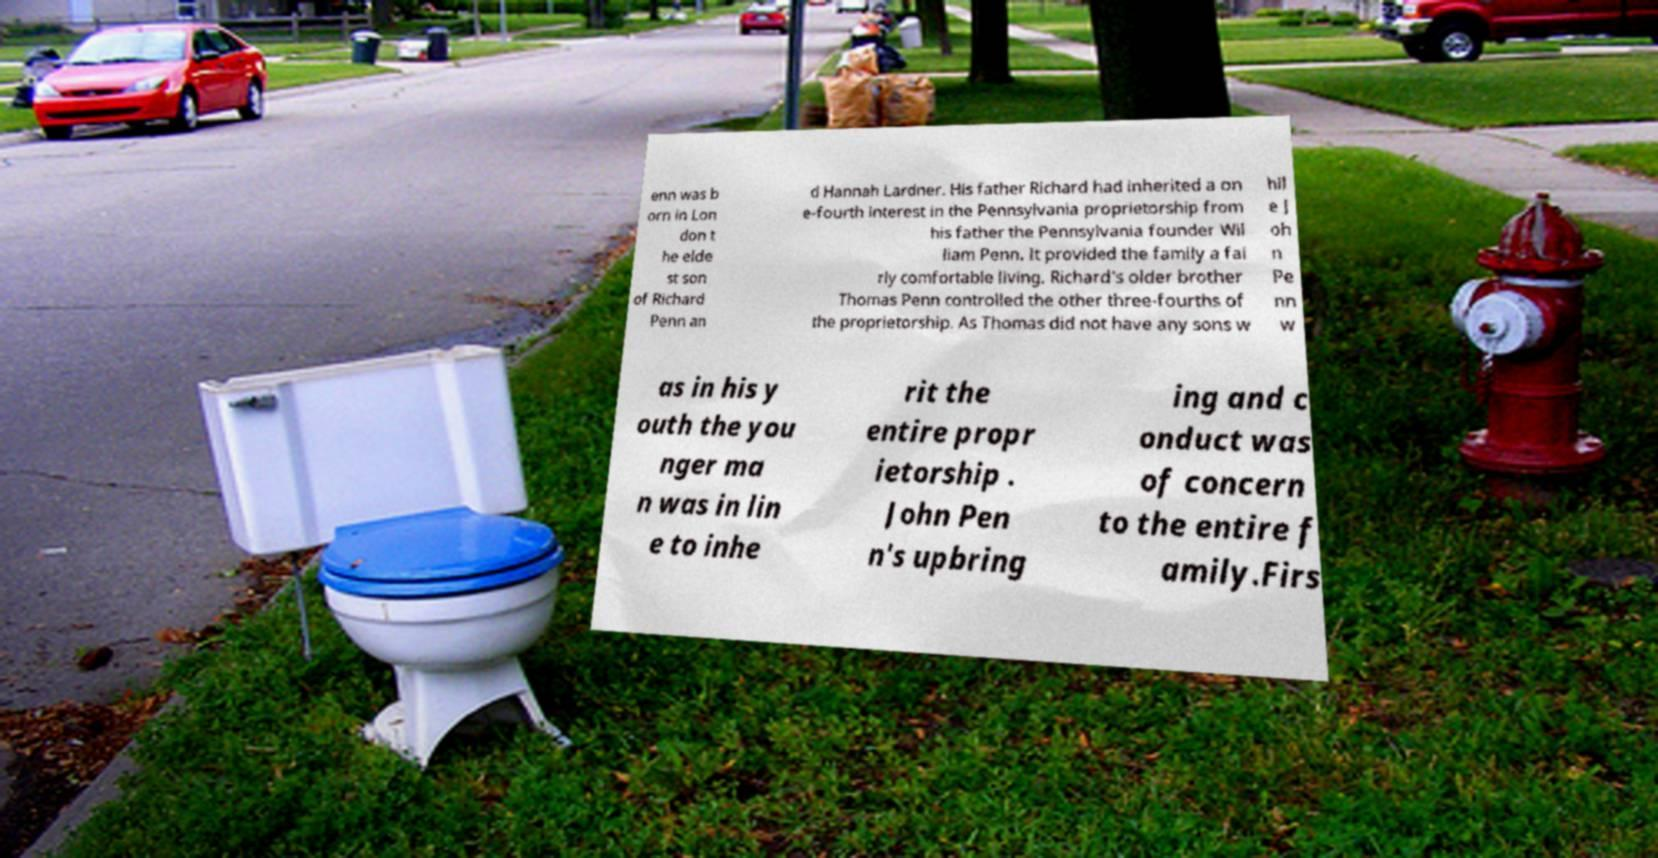There's text embedded in this image that I need extracted. Can you transcribe it verbatim? enn was b orn in Lon don t he elde st son of Richard Penn an d Hannah Lardner. His father Richard had inherited a on e-fourth interest in the Pennsylvania proprietorship from his father the Pennsylvania founder Wil liam Penn. It provided the family a fai rly comfortable living. Richard's older brother Thomas Penn controlled the other three-fourths of the proprietorship. As Thomas did not have any sons w hil e J oh n Pe nn w as in his y outh the you nger ma n was in lin e to inhe rit the entire propr ietorship . John Pen n's upbring ing and c onduct was of concern to the entire f amily.Firs 